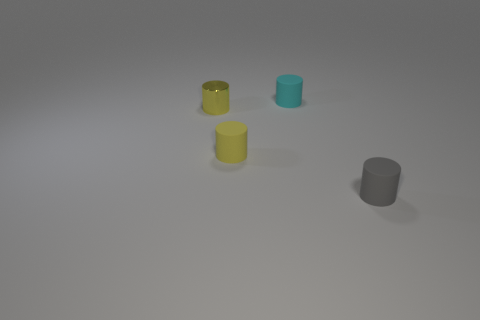Is there another small cylinder of the same color as the metal cylinder?
Make the answer very short. Yes. What is the color of the other metal cylinder that is the same size as the cyan cylinder?
Your answer should be compact. Yellow. How many tiny yellow objects are on the left side of the yellow cylinder that is right of the tiny yellow metallic cylinder?
Your answer should be very brief. 1. What number of objects are things that are in front of the cyan cylinder or small cyan matte things?
Make the answer very short. 4. How many other cylinders have the same material as the tiny cyan cylinder?
Provide a succinct answer. 2. There is a small rubber thing that is the same color as the metallic object; what shape is it?
Provide a short and direct response. Cylinder. Is the number of yellow cylinders right of the gray matte cylinder the same as the number of large cyan metal blocks?
Your response must be concise. Yes. What is the size of the rubber thing that is behind the shiny object?
Your response must be concise. Small. What number of tiny objects are either metal cylinders or rubber cylinders?
Provide a short and direct response. 4. What color is the tiny shiny thing that is the same shape as the small cyan rubber thing?
Give a very brief answer. Yellow. 